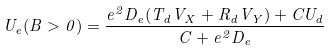<formula> <loc_0><loc_0><loc_500><loc_500>U _ { e } ( B > 0 ) = \frac { e ^ { 2 } D _ { e } ( T _ { d } V _ { X } + R _ { d } V _ { Y } ) + C U _ { d } } { C + e ^ { 2 } D _ { e } }</formula> 